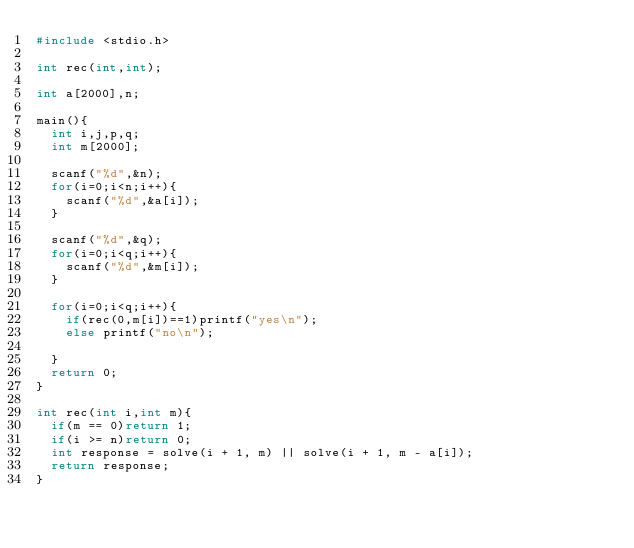Convert code to text. <code><loc_0><loc_0><loc_500><loc_500><_C_>#include <stdio.h>
 
int rec(int,int);
 
int a[2000],n;
 
main(){
  int i,j,p,q;
  int m[2000];
   
  scanf("%d",&n);
  for(i=0;i<n;i++){
    scanf("%d",&a[i]);
  } 
   
  scanf("%d",&q);
  for(i=0;i<q;i++){
    scanf("%d",&m[i]);
  }
   
  for(i=0;i<q;i++){
    if(rec(0,m[i])==1)printf("yes\n");
    else printf("no\n");
     
  }
  return 0;
}
 
int rec(int i,int m){
  if(m == 0)return 1;
  if(i >= n)return 0;
  int response = solve(i + 1, m) || solve(i + 1, m - a[i]);
  return response;
}</code> 